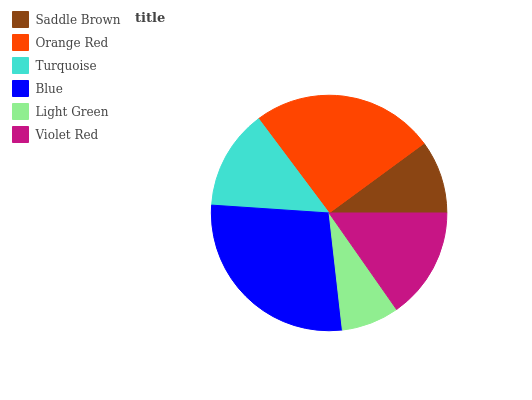Is Light Green the minimum?
Answer yes or no. Yes. Is Blue the maximum?
Answer yes or no. Yes. Is Orange Red the minimum?
Answer yes or no. No. Is Orange Red the maximum?
Answer yes or no. No. Is Orange Red greater than Saddle Brown?
Answer yes or no. Yes. Is Saddle Brown less than Orange Red?
Answer yes or no. Yes. Is Saddle Brown greater than Orange Red?
Answer yes or no. No. Is Orange Red less than Saddle Brown?
Answer yes or no. No. Is Violet Red the high median?
Answer yes or no. Yes. Is Turquoise the low median?
Answer yes or no. Yes. Is Blue the high median?
Answer yes or no. No. Is Blue the low median?
Answer yes or no. No. 